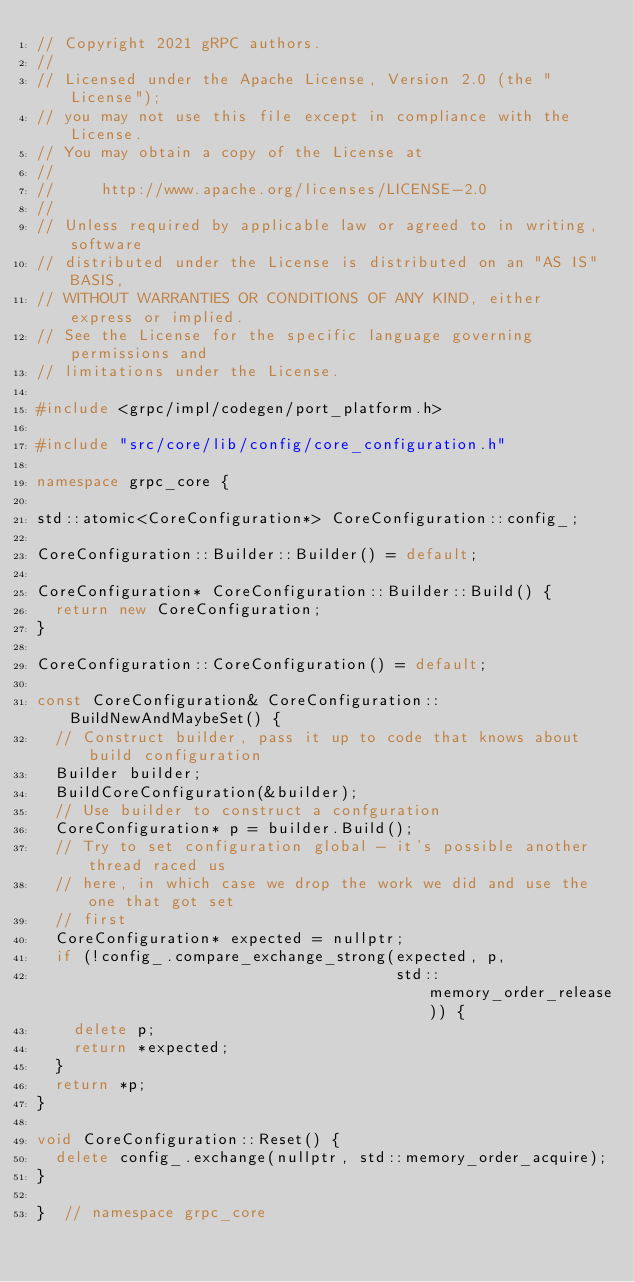Convert code to text. <code><loc_0><loc_0><loc_500><loc_500><_C++_>// Copyright 2021 gRPC authors.
//
// Licensed under the Apache License, Version 2.0 (the "License");
// you may not use this file except in compliance with the License.
// You may obtain a copy of the License at
//
//     http://www.apache.org/licenses/LICENSE-2.0
//
// Unless required by applicable law or agreed to in writing, software
// distributed under the License is distributed on an "AS IS" BASIS,
// WITHOUT WARRANTIES OR CONDITIONS OF ANY KIND, either express or implied.
// See the License for the specific language governing permissions and
// limitations under the License.

#include <grpc/impl/codegen/port_platform.h>

#include "src/core/lib/config/core_configuration.h"

namespace grpc_core {

std::atomic<CoreConfiguration*> CoreConfiguration::config_;

CoreConfiguration::Builder::Builder() = default;

CoreConfiguration* CoreConfiguration::Builder::Build() {
  return new CoreConfiguration;
}

CoreConfiguration::CoreConfiguration() = default;

const CoreConfiguration& CoreConfiguration::BuildNewAndMaybeSet() {
  // Construct builder, pass it up to code that knows about build configuration
  Builder builder;
  BuildCoreConfiguration(&builder);
  // Use builder to construct a confguration
  CoreConfiguration* p = builder.Build();
  // Try to set configuration global - it's possible another thread raced us
  // here, in which case we drop the work we did and use the one that got set
  // first
  CoreConfiguration* expected = nullptr;
  if (!config_.compare_exchange_strong(expected, p,
                                       std::memory_order_release)) {
    delete p;
    return *expected;
  }
  return *p;
}

void CoreConfiguration::Reset() {
  delete config_.exchange(nullptr, std::memory_order_acquire);
}

}  // namespace grpc_core
</code> 